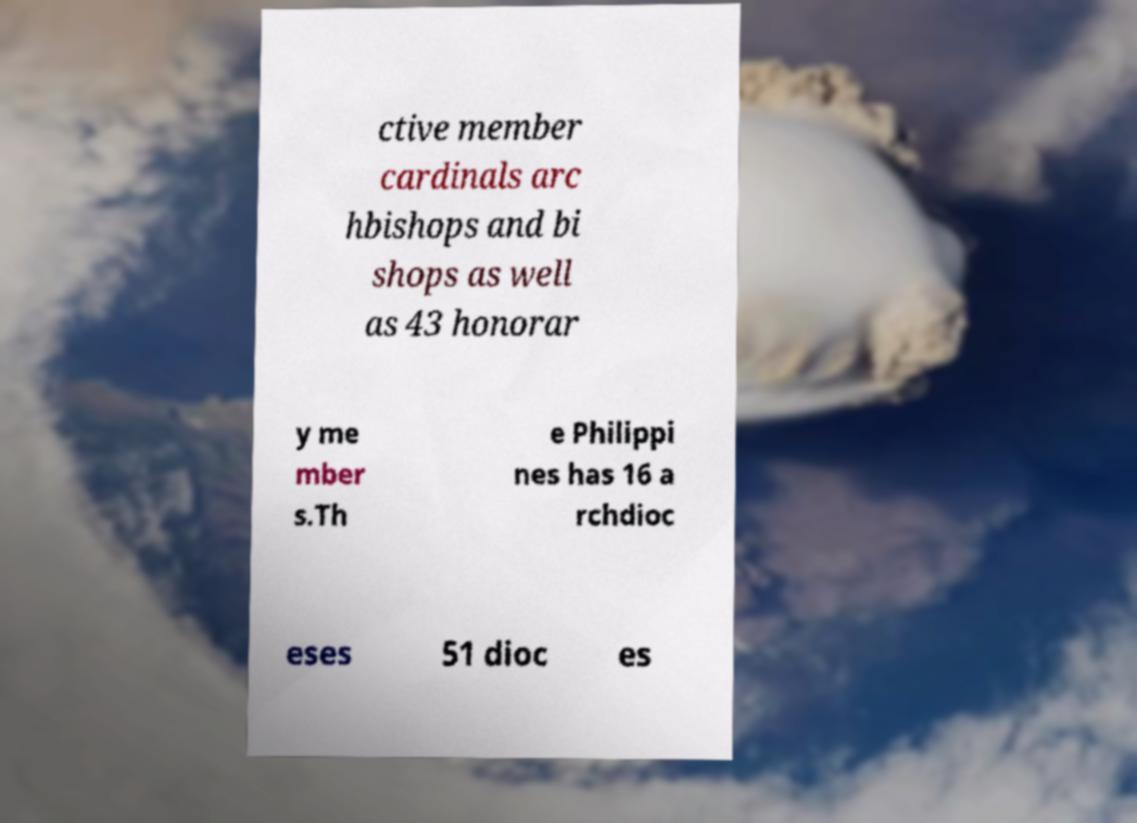Can you accurately transcribe the text from the provided image for me? ctive member cardinals arc hbishops and bi shops as well as 43 honorar y me mber s.Th e Philippi nes has 16 a rchdioc eses 51 dioc es 